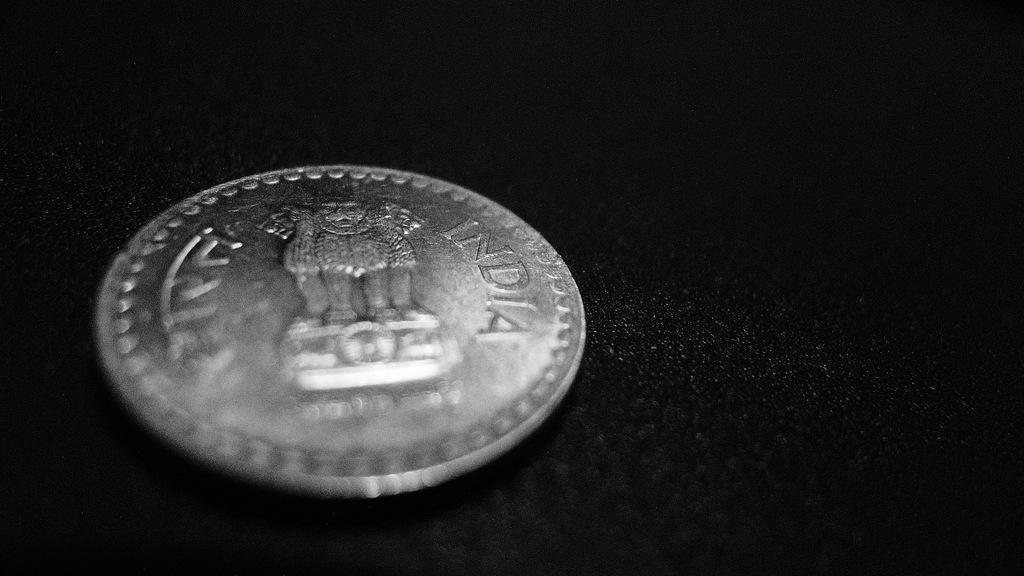Where is this coin from?
Ensure brevity in your answer.  India. 